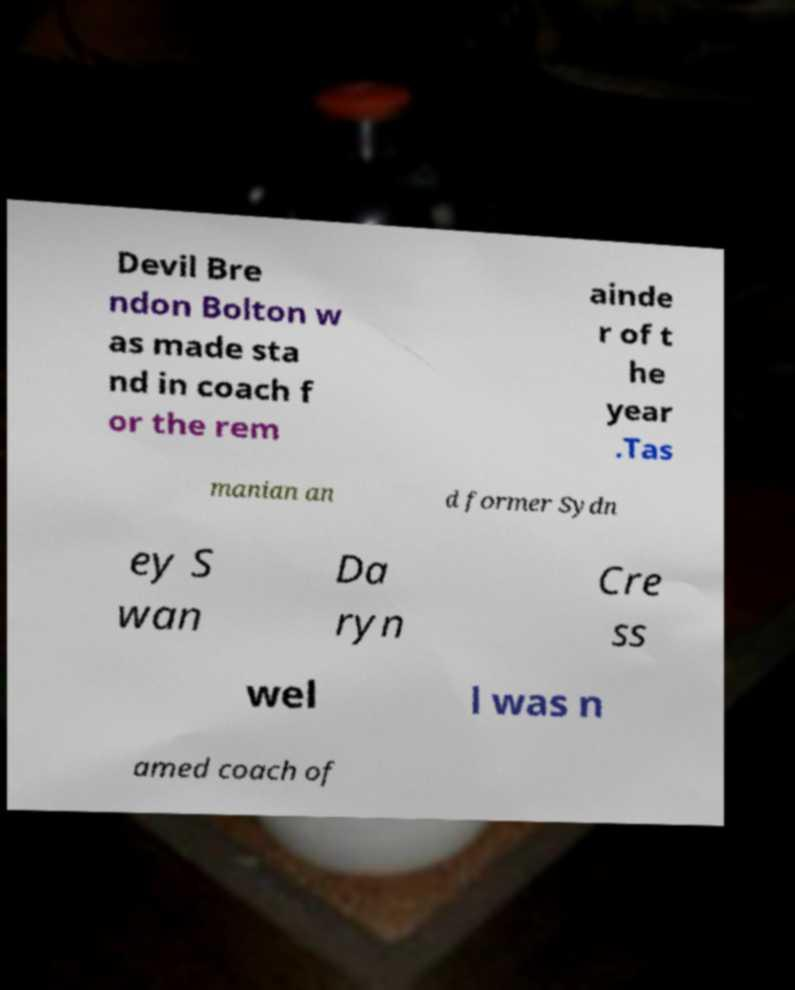Please identify and transcribe the text found in this image. Devil Bre ndon Bolton w as made sta nd in coach f or the rem ainde r of t he year .Tas manian an d former Sydn ey S wan Da ryn Cre ss wel l was n amed coach of 